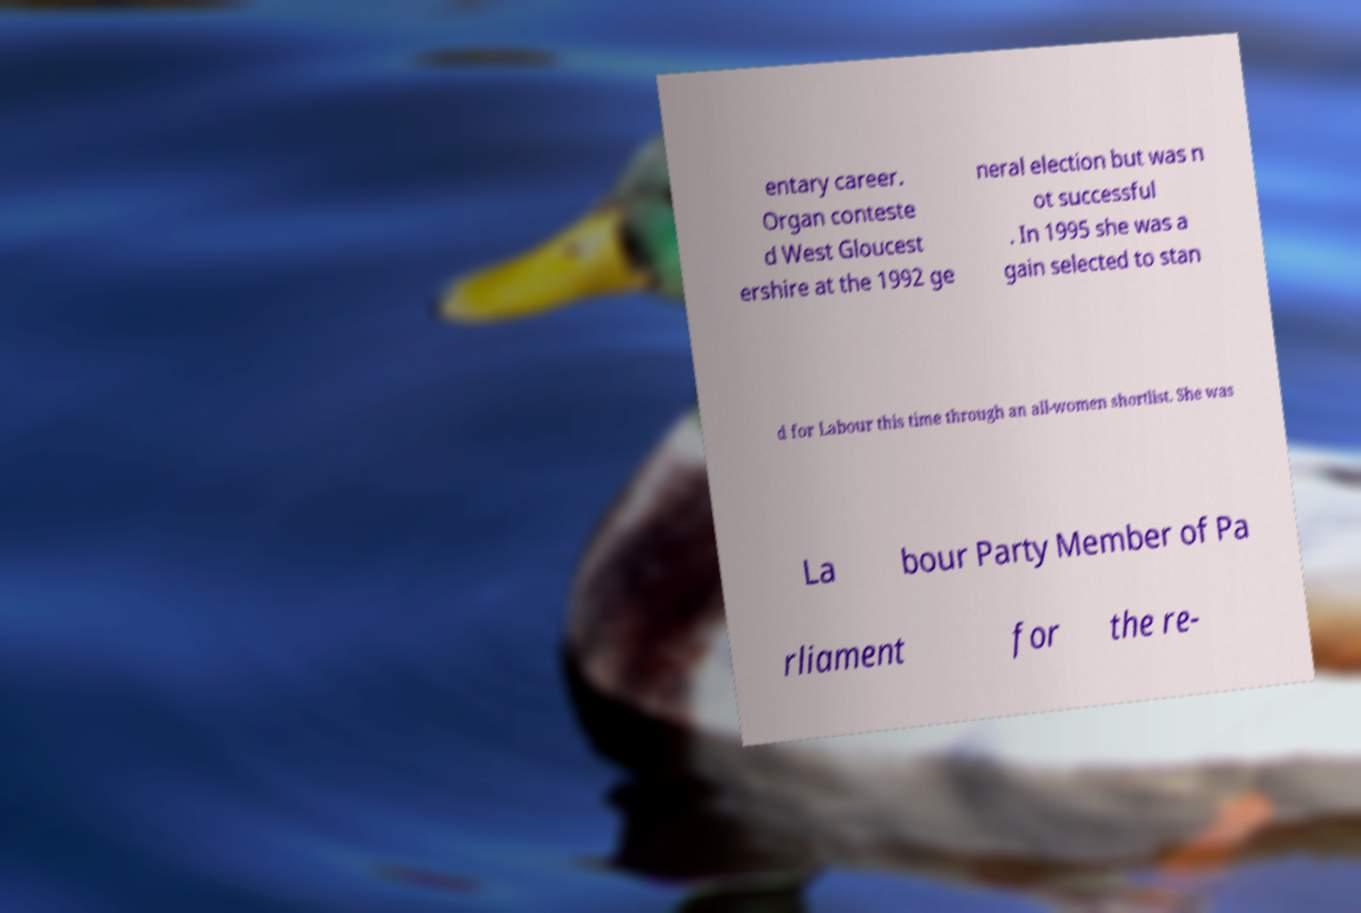Please identify and transcribe the text found in this image. entary career. Organ conteste d West Gloucest ershire at the 1992 ge neral election but was n ot successful . In 1995 she was a gain selected to stan d for Labour this time through an all-women shortlist. She was La bour Party Member of Pa rliament for the re- 